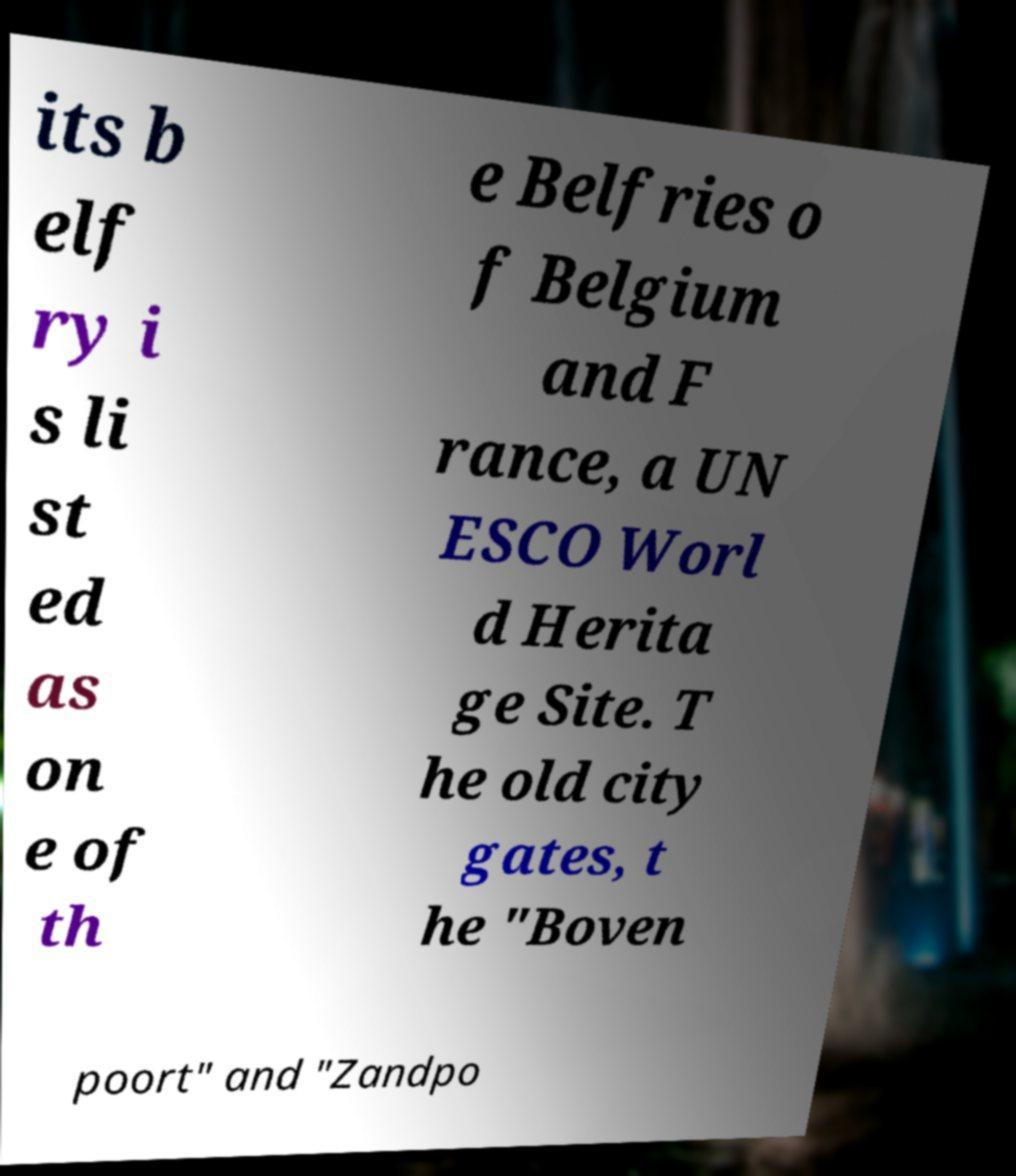Could you assist in decoding the text presented in this image and type it out clearly? its b elf ry i s li st ed as on e of th e Belfries o f Belgium and F rance, a UN ESCO Worl d Herita ge Site. T he old city gates, t he "Boven poort" and "Zandpo 